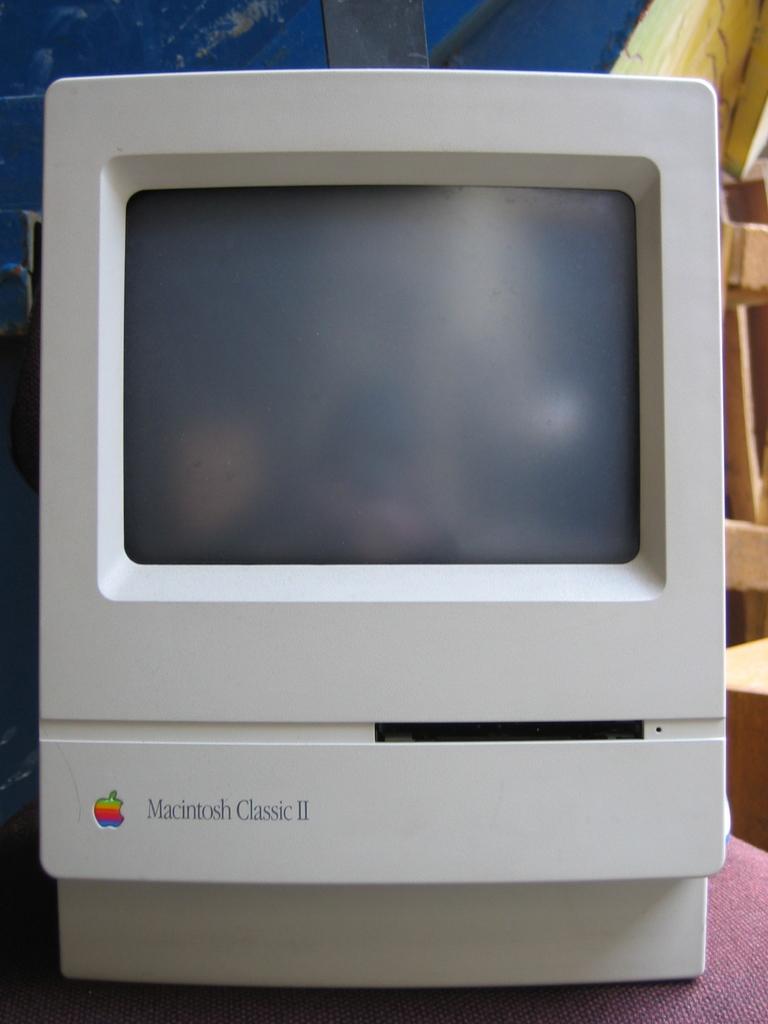That brand of computer is this?
Ensure brevity in your answer.  Macintosh. What version is it?
Make the answer very short. Macintosh classic ii. 